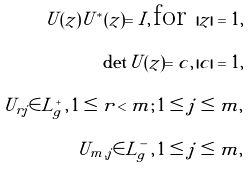<formula> <loc_0><loc_0><loc_500><loc_500>U ( z ) U ^ { * } ( z ) = I , \, \text {for } | z | = 1 , \\ \det U ( z ) = c , \, | c | = 1 , \\ U _ { r j } \in L ^ { + } _ { g } \, , \, 1 \leq r < m ; \, 1 \leq j \leq m , \\ U _ { m , j } \in L ^ { - } _ { g } \, , \, 1 \leq j \leq m ,</formula> 